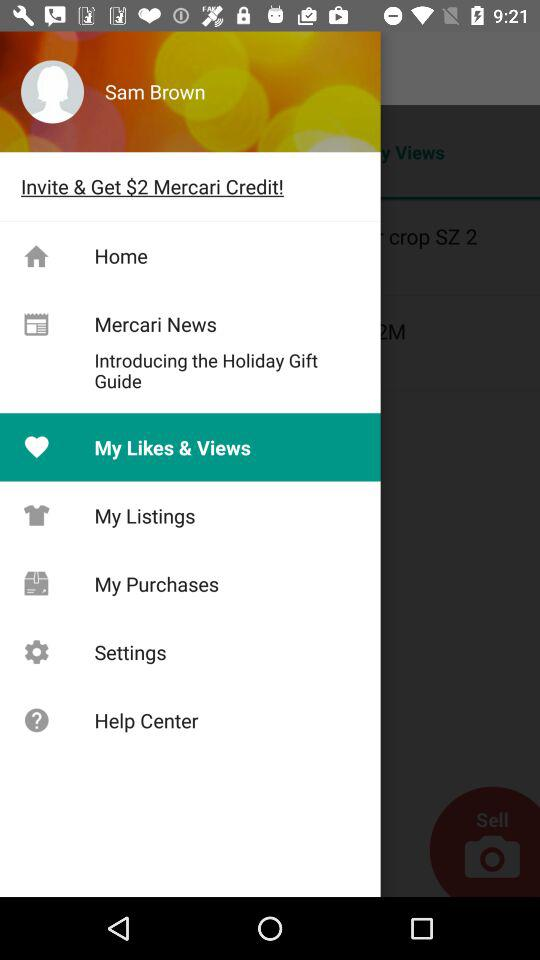What is the user name? The user name is Sam Brown. 